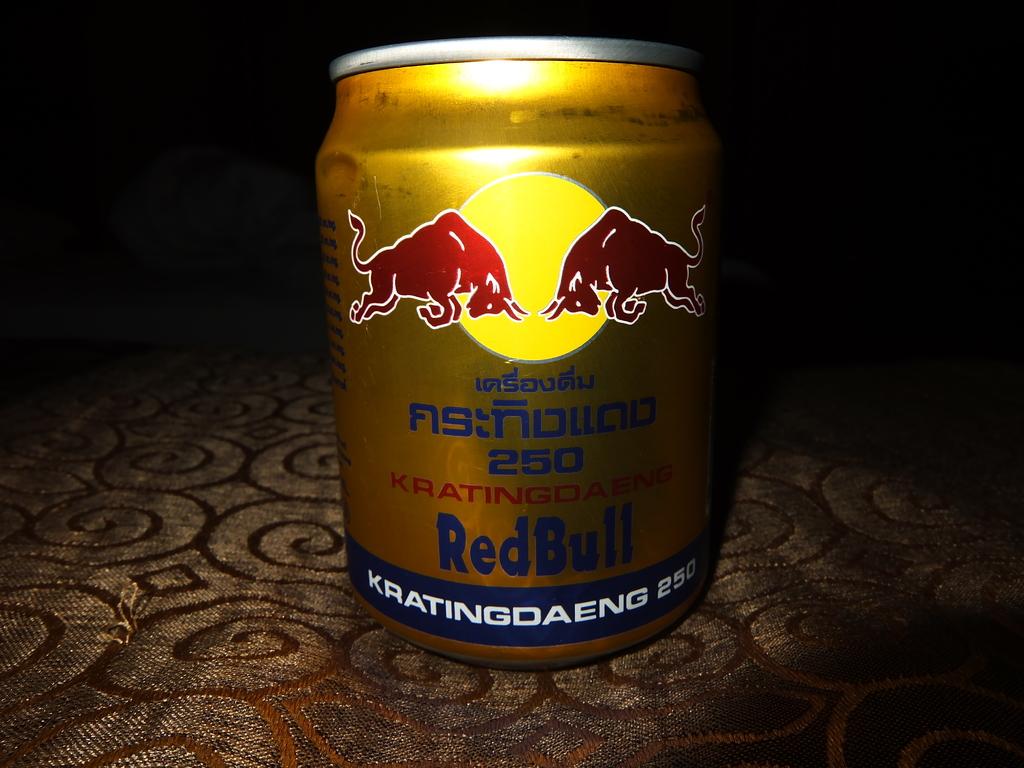What is the name of the beer?
Make the answer very short. Redbull. 